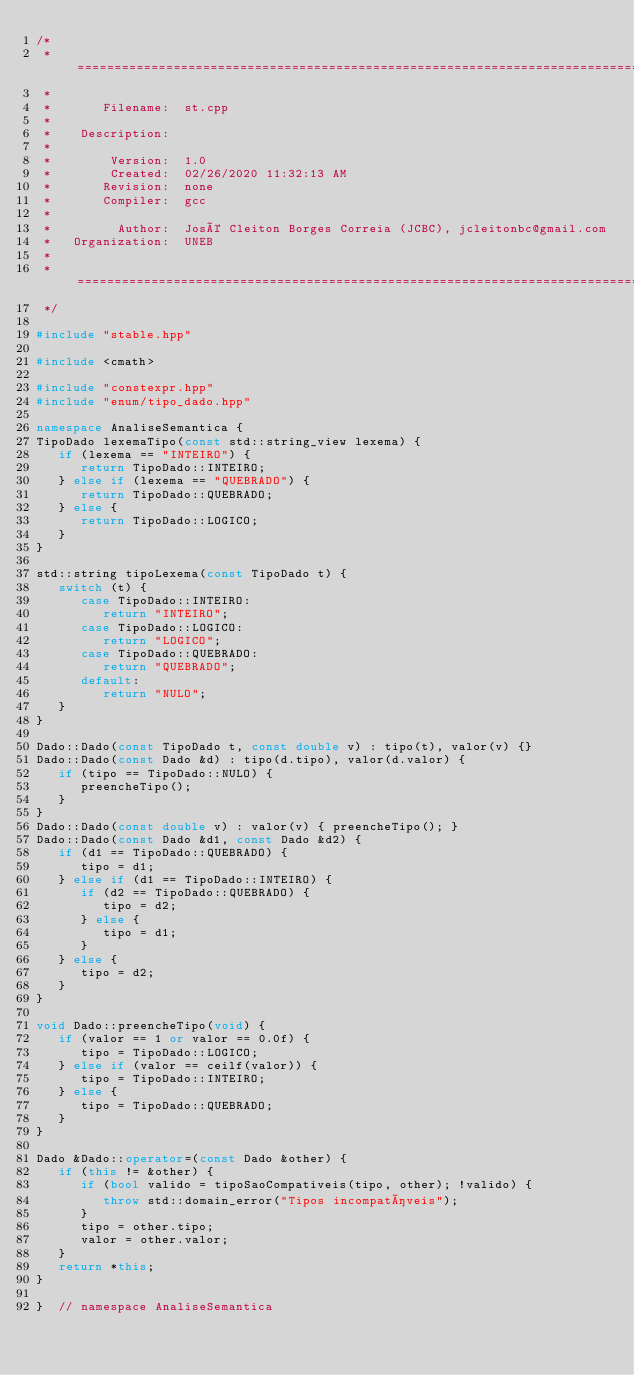<code> <loc_0><loc_0><loc_500><loc_500><_C++_>/*
 * =====================================================================================
 *
 *       Filename:  st.cpp
 *
 *    Description:
 *
 *        Version:  1.0
 *        Created:  02/26/2020 11:32:13 AM
 *       Revision:  none
 *       Compiler:  gcc
 *
 *         Author:  José Cleiton Borges Correia (JCBC), jcleitonbc@gmail.com
 *   Organization:  UNEB
 *
 * =====================================================================================
 */

#include "stable.hpp"

#include <cmath>

#include "constexpr.hpp"
#include "enum/tipo_dado.hpp"

namespace AnaliseSemantica {
TipoDado lexemaTipo(const std::string_view lexema) {
   if (lexema == "INTEIRO") {
      return TipoDado::INTEIRO;
   } else if (lexema == "QUEBRADO") {
      return TipoDado::QUEBRADO;
   } else {
      return TipoDado::LOGICO;
   }
}

std::string tipoLexema(const TipoDado t) {
   switch (t) {
      case TipoDado::INTEIRO:
         return "INTEIRO";
      case TipoDado::LOGICO:
         return "LOGICO";
      case TipoDado::QUEBRADO:
         return "QUEBRADO";
      default:
         return "NULO";
   }
}

Dado::Dado(const TipoDado t, const double v) : tipo(t), valor(v) {}
Dado::Dado(const Dado &d) : tipo(d.tipo), valor(d.valor) {
   if (tipo == TipoDado::NULO) {
      preencheTipo();
   }
}
Dado::Dado(const double v) : valor(v) { preencheTipo(); }
Dado::Dado(const Dado &d1, const Dado &d2) {
   if (d1 == TipoDado::QUEBRADO) {
      tipo = d1;
   } else if (d1 == TipoDado::INTEIRO) {
      if (d2 == TipoDado::QUEBRADO) {
         tipo = d2;
      } else {
         tipo = d1;
      }
   } else {
      tipo = d2;
   }
}

void Dado::preencheTipo(void) {
   if (valor == 1 or valor == 0.0f) {
      tipo = TipoDado::LOGICO;
   } else if (valor == ceilf(valor)) {
      tipo = TipoDado::INTEIRO;
   } else {
      tipo = TipoDado::QUEBRADO;
   }
}

Dado &Dado::operator=(const Dado &other) {
   if (this != &other) {
      if (bool valido = tipoSaoCompativeis(tipo, other); !valido) {
         throw std::domain_error("Tipos incompatíveis");
      }
      tipo = other.tipo;
      valor = other.valor;
   }
   return *this;
}

}  // namespace AnaliseSemantica
</code> 